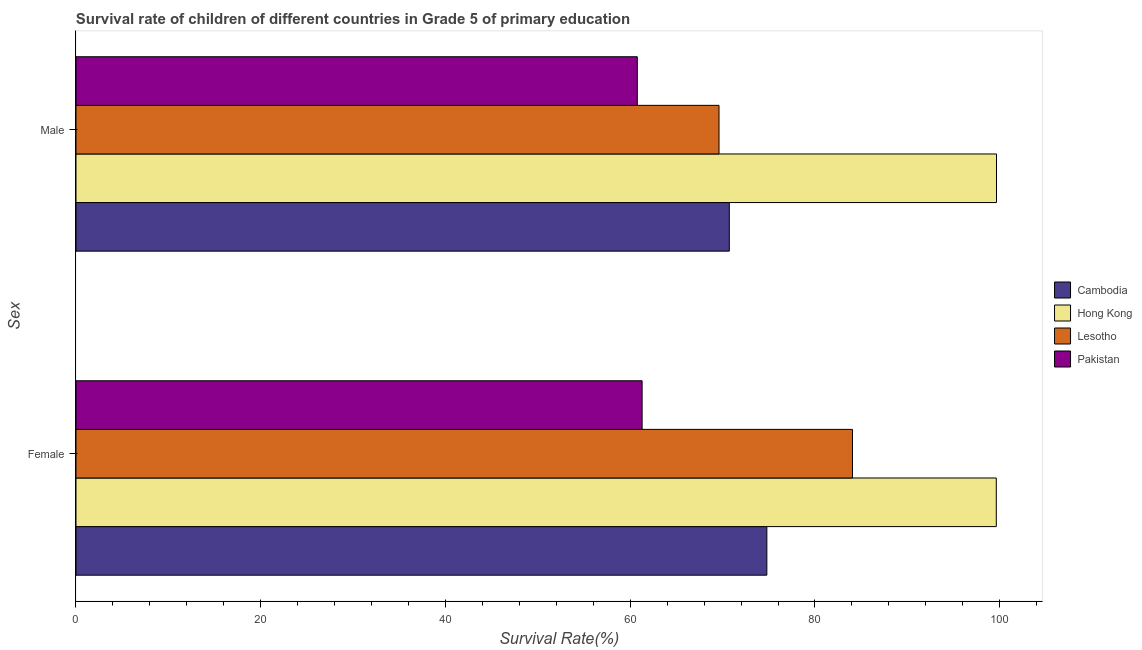How many groups of bars are there?
Provide a succinct answer. 2. Are the number of bars per tick equal to the number of legend labels?
Ensure brevity in your answer.  Yes. How many bars are there on the 1st tick from the top?
Ensure brevity in your answer.  4. What is the survival rate of female students in primary education in Lesotho?
Offer a terse response. 84.06. Across all countries, what is the maximum survival rate of female students in primary education?
Give a very brief answer. 99.63. Across all countries, what is the minimum survival rate of female students in primary education?
Offer a very short reply. 61.29. In which country was the survival rate of male students in primary education maximum?
Offer a very short reply. Hong Kong. What is the total survival rate of female students in primary education in the graph?
Your response must be concise. 319.77. What is the difference between the survival rate of female students in primary education in Pakistan and that in Lesotho?
Ensure brevity in your answer.  -22.77. What is the difference between the survival rate of male students in primary education in Cambodia and the survival rate of female students in primary education in Pakistan?
Provide a succinct answer. 9.44. What is the average survival rate of female students in primary education per country?
Your answer should be compact. 79.94. What is the difference between the survival rate of male students in primary education and survival rate of female students in primary education in Pakistan?
Provide a succinct answer. -0.52. What is the ratio of the survival rate of female students in primary education in Cambodia to that in Pakistan?
Your answer should be compact. 1.22. Is the survival rate of male students in primary education in Pakistan less than that in Lesotho?
Provide a succinct answer. Yes. In how many countries, is the survival rate of male students in primary education greater than the average survival rate of male students in primary education taken over all countries?
Your answer should be compact. 1. What does the 3rd bar from the top in Male represents?
Offer a very short reply. Hong Kong. How many bars are there?
Give a very brief answer. 8. Are all the bars in the graph horizontal?
Your answer should be compact. Yes. How many countries are there in the graph?
Offer a terse response. 4. What is the difference between two consecutive major ticks on the X-axis?
Make the answer very short. 20. Are the values on the major ticks of X-axis written in scientific E-notation?
Provide a short and direct response. No. How many legend labels are there?
Ensure brevity in your answer.  4. What is the title of the graph?
Make the answer very short. Survival rate of children of different countries in Grade 5 of primary education. What is the label or title of the X-axis?
Your answer should be compact. Survival Rate(%). What is the label or title of the Y-axis?
Make the answer very short. Sex. What is the Survival Rate(%) in Cambodia in Female?
Your answer should be very brief. 74.79. What is the Survival Rate(%) of Hong Kong in Female?
Your answer should be very brief. 99.63. What is the Survival Rate(%) in Lesotho in Female?
Your answer should be very brief. 84.06. What is the Survival Rate(%) in Pakistan in Female?
Give a very brief answer. 61.29. What is the Survival Rate(%) of Cambodia in Male?
Your answer should be compact. 70.73. What is the Survival Rate(%) of Hong Kong in Male?
Provide a succinct answer. 99.65. What is the Survival Rate(%) in Lesotho in Male?
Your response must be concise. 69.61. What is the Survival Rate(%) in Pakistan in Male?
Keep it short and to the point. 60.77. Across all Sex, what is the maximum Survival Rate(%) of Cambodia?
Your answer should be very brief. 74.79. Across all Sex, what is the maximum Survival Rate(%) in Hong Kong?
Your response must be concise. 99.65. Across all Sex, what is the maximum Survival Rate(%) in Lesotho?
Provide a succinct answer. 84.06. Across all Sex, what is the maximum Survival Rate(%) of Pakistan?
Provide a short and direct response. 61.29. Across all Sex, what is the minimum Survival Rate(%) of Cambodia?
Provide a succinct answer. 70.73. Across all Sex, what is the minimum Survival Rate(%) in Hong Kong?
Keep it short and to the point. 99.63. Across all Sex, what is the minimum Survival Rate(%) in Lesotho?
Provide a short and direct response. 69.61. Across all Sex, what is the minimum Survival Rate(%) of Pakistan?
Give a very brief answer. 60.77. What is the total Survival Rate(%) in Cambodia in the graph?
Ensure brevity in your answer.  145.52. What is the total Survival Rate(%) of Hong Kong in the graph?
Provide a short and direct response. 199.28. What is the total Survival Rate(%) of Lesotho in the graph?
Make the answer very short. 153.67. What is the total Survival Rate(%) in Pakistan in the graph?
Offer a very short reply. 122.05. What is the difference between the Survival Rate(%) in Cambodia in Female and that in Male?
Offer a very short reply. 4.06. What is the difference between the Survival Rate(%) in Hong Kong in Female and that in Male?
Keep it short and to the point. -0.02. What is the difference between the Survival Rate(%) of Lesotho in Female and that in Male?
Ensure brevity in your answer.  14.45. What is the difference between the Survival Rate(%) in Pakistan in Female and that in Male?
Make the answer very short. 0.52. What is the difference between the Survival Rate(%) of Cambodia in Female and the Survival Rate(%) of Hong Kong in Male?
Your answer should be very brief. -24.86. What is the difference between the Survival Rate(%) in Cambodia in Female and the Survival Rate(%) in Lesotho in Male?
Ensure brevity in your answer.  5.18. What is the difference between the Survival Rate(%) in Cambodia in Female and the Survival Rate(%) in Pakistan in Male?
Provide a succinct answer. 14.02. What is the difference between the Survival Rate(%) in Hong Kong in Female and the Survival Rate(%) in Lesotho in Male?
Your answer should be very brief. 30.02. What is the difference between the Survival Rate(%) of Hong Kong in Female and the Survival Rate(%) of Pakistan in Male?
Your answer should be very brief. 38.86. What is the difference between the Survival Rate(%) in Lesotho in Female and the Survival Rate(%) in Pakistan in Male?
Make the answer very short. 23.29. What is the average Survival Rate(%) in Cambodia per Sex?
Offer a terse response. 72.76. What is the average Survival Rate(%) in Hong Kong per Sex?
Offer a very short reply. 99.64. What is the average Survival Rate(%) in Lesotho per Sex?
Give a very brief answer. 76.84. What is the average Survival Rate(%) of Pakistan per Sex?
Your answer should be very brief. 61.03. What is the difference between the Survival Rate(%) of Cambodia and Survival Rate(%) of Hong Kong in Female?
Your answer should be compact. -24.84. What is the difference between the Survival Rate(%) in Cambodia and Survival Rate(%) in Lesotho in Female?
Provide a short and direct response. -9.27. What is the difference between the Survival Rate(%) of Cambodia and Survival Rate(%) of Pakistan in Female?
Make the answer very short. 13.5. What is the difference between the Survival Rate(%) of Hong Kong and Survival Rate(%) of Lesotho in Female?
Your response must be concise. 15.57. What is the difference between the Survival Rate(%) of Hong Kong and Survival Rate(%) of Pakistan in Female?
Make the answer very short. 38.34. What is the difference between the Survival Rate(%) of Lesotho and Survival Rate(%) of Pakistan in Female?
Make the answer very short. 22.77. What is the difference between the Survival Rate(%) of Cambodia and Survival Rate(%) of Hong Kong in Male?
Your answer should be compact. -28.92. What is the difference between the Survival Rate(%) in Cambodia and Survival Rate(%) in Lesotho in Male?
Keep it short and to the point. 1.12. What is the difference between the Survival Rate(%) of Cambodia and Survival Rate(%) of Pakistan in Male?
Provide a succinct answer. 9.96. What is the difference between the Survival Rate(%) in Hong Kong and Survival Rate(%) in Lesotho in Male?
Provide a succinct answer. 30.04. What is the difference between the Survival Rate(%) in Hong Kong and Survival Rate(%) in Pakistan in Male?
Offer a terse response. 38.89. What is the difference between the Survival Rate(%) in Lesotho and Survival Rate(%) in Pakistan in Male?
Make the answer very short. 8.85. What is the ratio of the Survival Rate(%) of Cambodia in Female to that in Male?
Your answer should be very brief. 1.06. What is the ratio of the Survival Rate(%) in Lesotho in Female to that in Male?
Ensure brevity in your answer.  1.21. What is the ratio of the Survival Rate(%) in Pakistan in Female to that in Male?
Your answer should be very brief. 1.01. What is the difference between the highest and the second highest Survival Rate(%) in Cambodia?
Offer a terse response. 4.06. What is the difference between the highest and the second highest Survival Rate(%) of Hong Kong?
Give a very brief answer. 0.02. What is the difference between the highest and the second highest Survival Rate(%) of Lesotho?
Your answer should be compact. 14.45. What is the difference between the highest and the second highest Survival Rate(%) in Pakistan?
Ensure brevity in your answer.  0.52. What is the difference between the highest and the lowest Survival Rate(%) in Cambodia?
Ensure brevity in your answer.  4.06. What is the difference between the highest and the lowest Survival Rate(%) in Hong Kong?
Give a very brief answer. 0.02. What is the difference between the highest and the lowest Survival Rate(%) of Lesotho?
Offer a terse response. 14.45. What is the difference between the highest and the lowest Survival Rate(%) in Pakistan?
Give a very brief answer. 0.52. 